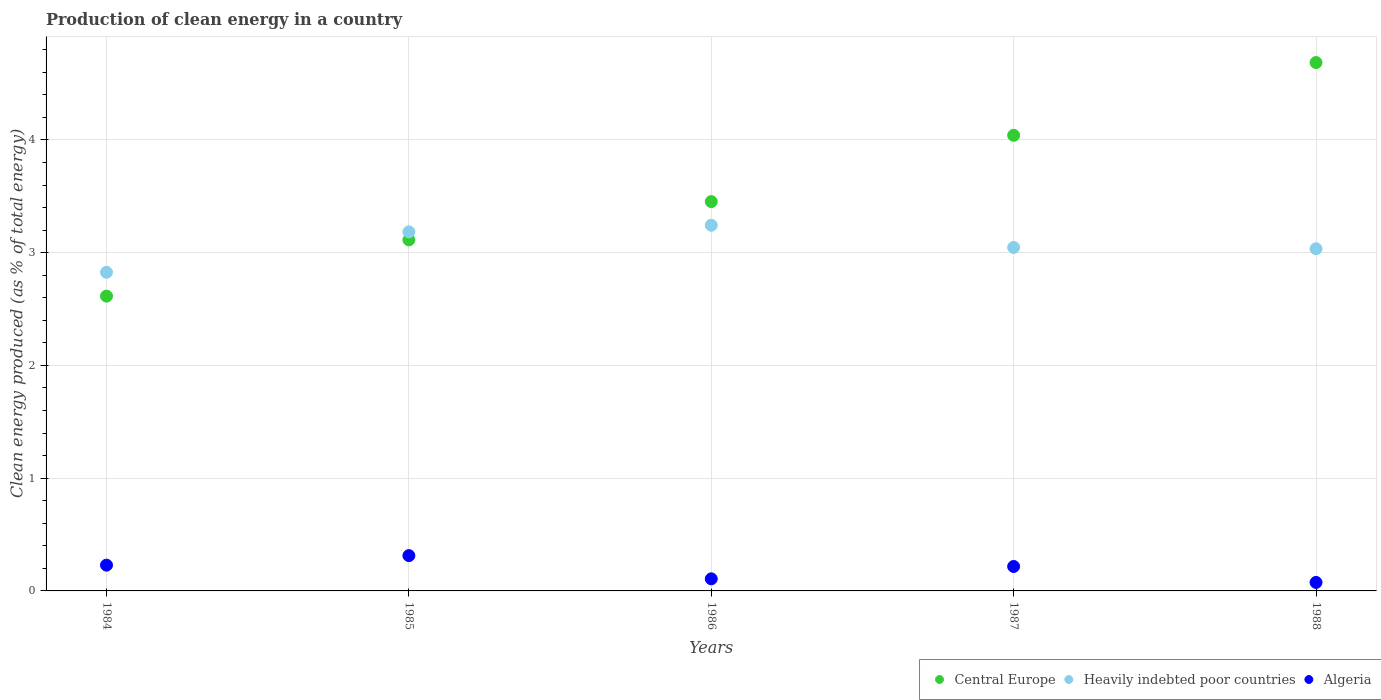How many different coloured dotlines are there?
Keep it short and to the point. 3. What is the percentage of clean energy produced in Algeria in 1988?
Your response must be concise. 0.08. Across all years, what is the maximum percentage of clean energy produced in Central Europe?
Give a very brief answer. 4.69. Across all years, what is the minimum percentage of clean energy produced in Heavily indebted poor countries?
Your answer should be very brief. 2.83. In which year was the percentage of clean energy produced in Central Europe minimum?
Offer a terse response. 1984. What is the total percentage of clean energy produced in Heavily indebted poor countries in the graph?
Provide a short and direct response. 15.34. What is the difference between the percentage of clean energy produced in Algeria in 1985 and that in 1988?
Your response must be concise. 0.24. What is the difference between the percentage of clean energy produced in Algeria in 1985 and the percentage of clean energy produced in Central Europe in 1988?
Keep it short and to the point. -4.37. What is the average percentage of clean energy produced in Heavily indebted poor countries per year?
Your answer should be very brief. 3.07. In the year 1984, what is the difference between the percentage of clean energy produced in Central Europe and percentage of clean energy produced in Algeria?
Your answer should be very brief. 2.39. What is the ratio of the percentage of clean energy produced in Heavily indebted poor countries in 1984 to that in 1985?
Keep it short and to the point. 0.89. Is the percentage of clean energy produced in Central Europe in 1986 less than that in 1988?
Provide a succinct answer. Yes. Is the difference between the percentage of clean energy produced in Central Europe in 1984 and 1985 greater than the difference between the percentage of clean energy produced in Algeria in 1984 and 1985?
Offer a very short reply. No. What is the difference between the highest and the second highest percentage of clean energy produced in Heavily indebted poor countries?
Your answer should be very brief. 0.06. What is the difference between the highest and the lowest percentage of clean energy produced in Central Europe?
Offer a very short reply. 2.07. In how many years, is the percentage of clean energy produced in Heavily indebted poor countries greater than the average percentage of clean energy produced in Heavily indebted poor countries taken over all years?
Ensure brevity in your answer.  2. Is the percentage of clean energy produced in Heavily indebted poor countries strictly greater than the percentage of clean energy produced in Algeria over the years?
Make the answer very short. Yes. How many dotlines are there?
Your response must be concise. 3. How many years are there in the graph?
Provide a short and direct response. 5. Does the graph contain grids?
Your answer should be compact. Yes. Where does the legend appear in the graph?
Offer a terse response. Bottom right. How many legend labels are there?
Provide a short and direct response. 3. How are the legend labels stacked?
Keep it short and to the point. Horizontal. What is the title of the graph?
Make the answer very short. Production of clean energy in a country. What is the label or title of the Y-axis?
Provide a short and direct response. Clean energy produced (as % of total energy). What is the Clean energy produced (as % of total energy) in Central Europe in 1984?
Ensure brevity in your answer.  2.61. What is the Clean energy produced (as % of total energy) in Heavily indebted poor countries in 1984?
Your answer should be compact. 2.83. What is the Clean energy produced (as % of total energy) in Algeria in 1984?
Give a very brief answer. 0.23. What is the Clean energy produced (as % of total energy) in Central Europe in 1985?
Make the answer very short. 3.11. What is the Clean energy produced (as % of total energy) of Heavily indebted poor countries in 1985?
Provide a succinct answer. 3.18. What is the Clean energy produced (as % of total energy) of Algeria in 1985?
Keep it short and to the point. 0.31. What is the Clean energy produced (as % of total energy) in Central Europe in 1986?
Provide a short and direct response. 3.45. What is the Clean energy produced (as % of total energy) in Heavily indebted poor countries in 1986?
Your answer should be very brief. 3.24. What is the Clean energy produced (as % of total energy) of Algeria in 1986?
Provide a short and direct response. 0.11. What is the Clean energy produced (as % of total energy) of Central Europe in 1987?
Offer a very short reply. 4.04. What is the Clean energy produced (as % of total energy) in Heavily indebted poor countries in 1987?
Offer a terse response. 3.05. What is the Clean energy produced (as % of total energy) of Algeria in 1987?
Provide a short and direct response. 0.22. What is the Clean energy produced (as % of total energy) in Central Europe in 1988?
Provide a short and direct response. 4.69. What is the Clean energy produced (as % of total energy) in Heavily indebted poor countries in 1988?
Give a very brief answer. 3.04. What is the Clean energy produced (as % of total energy) of Algeria in 1988?
Provide a short and direct response. 0.08. Across all years, what is the maximum Clean energy produced (as % of total energy) of Central Europe?
Your answer should be very brief. 4.69. Across all years, what is the maximum Clean energy produced (as % of total energy) in Heavily indebted poor countries?
Make the answer very short. 3.24. Across all years, what is the maximum Clean energy produced (as % of total energy) in Algeria?
Ensure brevity in your answer.  0.31. Across all years, what is the minimum Clean energy produced (as % of total energy) of Central Europe?
Offer a very short reply. 2.61. Across all years, what is the minimum Clean energy produced (as % of total energy) in Heavily indebted poor countries?
Your answer should be very brief. 2.83. Across all years, what is the minimum Clean energy produced (as % of total energy) of Algeria?
Provide a succinct answer. 0.08. What is the total Clean energy produced (as % of total energy) of Central Europe in the graph?
Ensure brevity in your answer.  17.91. What is the total Clean energy produced (as % of total energy) in Heavily indebted poor countries in the graph?
Offer a very short reply. 15.34. What is the difference between the Clean energy produced (as % of total energy) of Central Europe in 1984 and that in 1985?
Give a very brief answer. -0.5. What is the difference between the Clean energy produced (as % of total energy) of Heavily indebted poor countries in 1984 and that in 1985?
Provide a succinct answer. -0.36. What is the difference between the Clean energy produced (as % of total energy) of Algeria in 1984 and that in 1985?
Give a very brief answer. -0.08. What is the difference between the Clean energy produced (as % of total energy) of Central Europe in 1984 and that in 1986?
Your response must be concise. -0.84. What is the difference between the Clean energy produced (as % of total energy) in Heavily indebted poor countries in 1984 and that in 1986?
Provide a short and direct response. -0.42. What is the difference between the Clean energy produced (as % of total energy) in Algeria in 1984 and that in 1986?
Offer a very short reply. 0.12. What is the difference between the Clean energy produced (as % of total energy) of Central Europe in 1984 and that in 1987?
Offer a very short reply. -1.43. What is the difference between the Clean energy produced (as % of total energy) of Heavily indebted poor countries in 1984 and that in 1987?
Your answer should be very brief. -0.22. What is the difference between the Clean energy produced (as % of total energy) of Algeria in 1984 and that in 1987?
Provide a succinct answer. 0.01. What is the difference between the Clean energy produced (as % of total energy) in Central Europe in 1984 and that in 1988?
Your response must be concise. -2.07. What is the difference between the Clean energy produced (as % of total energy) in Heavily indebted poor countries in 1984 and that in 1988?
Provide a succinct answer. -0.21. What is the difference between the Clean energy produced (as % of total energy) in Algeria in 1984 and that in 1988?
Your answer should be compact. 0.15. What is the difference between the Clean energy produced (as % of total energy) of Central Europe in 1985 and that in 1986?
Make the answer very short. -0.34. What is the difference between the Clean energy produced (as % of total energy) in Heavily indebted poor countries in 1985 and that in 1986?
Provide a short and direct response. -0.06. What is the difference between the Clean energy produced (as % of total energy) of Algeria in 1985 and that in 1986?
Make the answer very short. 0.21. What is the difference between the Clean energy produced (as % of total energy) in Central Europe in 1985 and that in 1987?
Your answer should be very brief. -0.93. What is the difference between the Clean energy produced (as % of total energy) in Heavily indebted poor countries in 1985 and that in 1987?
Your response must be concise. 0.14. What is the difference between the Clean energy produced (as % of total energy) in Algeria in 1985 and that in 1987?
Your response must be concise. 0.1. What is the difference between the Clean energy produced (as % of total energy) in Central Europe in 1985 and that in 1988?
Give a very brief answer. -1.57. What is the difference between the Clean energy produced (as % of total energy) in Heavily indebted poor countries in 1985 and that in 1988?
Your answer should be very brief. 0.15. What is the difference between the Clean energy produced (as % of total energy) of Algeria in 1985 and that in 1988?
Give a very brief answer. 0.24. What is the difference between the Clean energy produced (as % of total energy) of Central Europe in 1986 and that in 1987?
Offer a very short reply. -0.59. What is the difference between the Clean energy produced (as % of total energy) of Heavily indebted poor countries in 1986 and that in 1987?
Keep it short and to the point. 0.2. What is the difference between the Clean energy produced (as % of total energy) in Algeria in 1986 and that in 1987?
Your response must be concise. -0.11. What is the difference between the Clean energy produced (as % of total energy) in Central Europe in 1986 and that in 1988?
Give a very brief answer. -1.23. What is the difference between the Clean energy produced (as % of total energy) of Heavily indebted poor countries in 1986 and that in 1988?
Your answer should be very brief. 0.21. What is the difference between the Clean energy produced (as % of total energy) in Algeria in 1986 and that in 1988?
Your answer should be very brief. 0.03. What is the difference between the Clean energy produced (as % of total energy) of Central Europe in 1987 and that in 1988?
Keep it short and to the point. -0.65. What is the difference between the Clean energy produced (as % of total energy) of Heavily indebted poor countries in 1987 and that in 1988?
Ensure brevity in your answer.  0.01. What is the difference between the Clean energy produced (as % of total energy) in Algeria in 1987 and that in 1988?
Ensure brevity in your answer.  0.14. What is the difference between the Clean energy produced (as % of total energy) of Central Europe in 1984 and the Clean energy produced (as % of total energy) of Heavily indebted poor countries in 1985?
Keep it short and to the point. -0.57. What is the difference between the Clean energy produced (as % of total energy) in Central Europe in 1984 and the Clean energy produced (as % of total energy) in Algeria in 1985?
Offer a terse response. 2.3. What is the difference between the Clean energy produced (as % of total energy) of Heavily indebted poor countries in 1984 and the Clean energy produced (as % of total energy) of Algeria in 1985?
Make the answer very short. 2.51. What is the difference between the Clean energy produced (as % of total energy) of Central Europe in 1984 and the Clean energy produced (as % of total energy) of Heavily indebted poor countries in 1986?
Ensure brevity in your answer.  -0.63. What is the difference between the Clean energy produced (as % of total energy) in Central Europe in 1984 and the Clean energy produced (as % of total energy) in Algeria in 1986?
Make the answer very short. 2.51. What is the difference between the Clean energy produced (as % of total energy) in Heavily indebted poor countries in 1984 and the Clean energy produced (as % of total energy) in Algeria in 1986?
Make the answer very short. 2.72. What is the difference between the Clean energy produced (as % of total energy) of Central Europe in 1984 and the Clean energy produced (as % of total energy) of Heavily indebted poor countries in 1987?
Your response must be concise. -0.43. What is the difference between the Clean energy produced (as % of total energy) in Central Europe in 1984 and the Clean energy produced (as % of total energy) in Algeria in 1987?
Your answer should be very brief. 2.4. What is the difference between the Clean energy produced (as % of total energy) in Heavily indebted poor countries in 1984 and the Clean energy produced (as % of total energy) in Algeria in 1987?
Offer a terse response. 2.61. What is the difference between the Clean energy produced (as % of total energy) of Central Europe in 1984 and the Clean energy produced (as % of total energy) of Heavily indebted poor countries in 1988?
Your response must be concise. -0.42. What is the difference between the Clean energy produced (as % of total energy) of Central Europe in 1984 and the Clean energy produced (as % of total energy) of Algeria in 1988?
Provide a succinct answer. 2.54. What is the difference between the Clean energy produced (as % of total energy) in Heavily indebted poor countries in 1984 and the Clean energy produced (as % of total energy) in Algeria in 1988?
Your answer should be compact. 2.75. What is the difference between the Clean energy produced (as % of total energy) in Central Europe in 1985 and the Clean energy produced (as % of total energy) in Heavily indebted poor countries in 1986?
Provide a short and direct response. -0.13. What is the difference between the Clean energy produced (as % of total energy) in Central Europe in 1985 and the Clean energy produced (as % of total energy) in Algeria in 1986?
Ensure brevity in your answer.  3.01. What is the difference between the Clean energy produced (as % of total energy) of Heavily indebted poor countries in 1985 and the Clean energy produced (as % of total energy) of Algeria in 1986?
Offer a very short reply. 3.08. What is the difference between the Clean energy produced (as % of total energy) in Central Europe in 1985 and the Clean energy produced (as % of total energy) in Heavily indebted poor countries in 1987?
Ensure brevity in your answer.  0.07. What is the difference between the Clean energy produced (as % of total energy) of Central Europe in 1985 and the Clean energy produced (as % of total energy) of Algeria in 1987?
Give a very brief answer. 2.9. What is the difference between the Clean energy produced (as % of total energy) of Heavily indebted poor countries in 1985 and the Clean energy produced (as % of total energy) of Algeria in 1987?
Ensure brevity in your answer.  2.97. What is the difference between the Clean energy produced (as % of total energy) in Central Europe in 1985 and the Clean energy produced (as % of total energy) in Heavily indebted poor countries in 1988?
Your response must be concise. 0.08. What is the difference between the Clean energy produced (as % of total energy) in Central Europe in 1985 and the Clean energy produced (as % of total energy) in Algeria in 1988?
Provide a short and direct response. 3.04. What is the difference between the Clean energy produced (as % of total energy) in Heavily indebted poor countries in 1985 and the Clean energy produced (as % of total energy) in Algeria in 1988?
Ensure brevity in your answer.  3.11. What is the difference between the Clean energy produced (as % of total energy) in Central Europe in 1986 and the Clean energy produced (as % of total energy) in Heavily indebted poor countries in 1987?
Offer a terse response. 0.41. What is the difference between the Clean energy produced (as % of total energy) of Central Europe in 1986 and the Clean energy produced (as % of total energy) of Algeria in 1987?
Make the answer very short. 3.24. What is the difference between the Clean energy produced (as % of total energy) in Heavily indebted poor countries in 1986 and the Clean energy produced (as % of total energy) in Algeria in 1987?
Your answer should be very brief. 3.03. What is the difference between the Clean energy produced (as % of total energy) of Central Europe in 1986 and the Clean energy produced (as % of total energy) of Heavily indebted poor countries in 1988?
Ensure brevity in your answer.  0.42. What is the difference between the Clean energy produced (as % of total energy) of Central Europe in 1986 and the Clean energy produced (as % of total energy) of Algeria in 1988?
Give a very brief answer. 3.38. What is the difference between the Clean energy produced (as % of total energy) in Heavily indebted poor countries in 1986 and the Clean energy produced (as % of total energy) in Algeria in 1988?
Offer a very short reply. 3.17. What is the difference between the Clean energy produced (as % of total energy) in Central Europe in 1987 and the Clean energy produced (as % of total energy) in Heavily indebted poor countries in 1988?
Provide a succinct answer. 1.01. What is the difference between the Clean energy produced (as % of total energy) in Central Europe in 1987 and the Clean energy produced (as % of total energy) in Algeria in 1988?
Offer a terse response. 3.97. What is the difference between the Clean energy produced (as % of total energy) in Heavily indebted poor countries in 1987 and the Clean energy produced (as % of total energy) in Algeria in 1988?
Make the answer very short. 2.97. What is the average Clean energy produced (as % of total energy) of Central Europe per year?
Give a very brief answer. 3.58. What is the average Clean energy produced (as % of total energy) in Heavily indebted poor countries per year?
Ensure brevity in your answer.  3.07. What is the average Clean energy produced (as % of total energy) in Algeria per year?
Offer a terse response. 0.19. In the year 1984, what is the difference between the Clean energy produced (as % of total energy) in Central Europe and Clean energy produced (as % of total energy) in Heavily indebted poor countries?
Your response must be concise. -0.21. In the year 1984, what is the difference between the Clean energy produced (as % of total energy) of Central Europe and Clean energy produced (as % of total energy) of Algeria?
Make the answer very short. 2.39. In the year 1984, what is the difference between the Clean energy produced (as % of total energy) in Heavily indebted poor countries and Clean energy produced (as % of total energy) in Algeria?
Keep it short and to the point. 2.6. In the year 1985, what is the difference between the Clean energy produced (as % of total energy) in Central Europe and Clean energy produced (as % of total energy) in Heavily indebted poor countries?
Provide a short and direct response. -0.07. In the year 1985, what is the difference between the Clean energy produced (as % of total energy) of Central Europe and Clean energy produced (as % of total energy) of Algeria?
Provide a short and direct response. 2.8. In the year 1985, what is the difference between the Clean energy produced (as % of total energy) in Heavily indebted poor countries and Clean energy produced (as % of total energy) in Algeria?
Offer a terse response. 2.87. In the year 1986, what is the difference between the Clean energy produced (as % of total energy) in Central Europe and Clean energy produced (as % of total energy) in Heavily indebted poor countries?
Make the answer very short. 0.21. In the year 1986, what is the difference between the Clean energy produced (as % of total energy) in Central Europe and Clean energy produced (as % of total energy) in Algeria?
Give a very brief answer. 3.35. In the year 1986, what is the difference between the Clean energy produced (as % of total energy) in Heavily indebted poor countries and Clean energy produced (as % of total energy) in Algeria?
Your response must be concise. 3.14. In the year 1987, what is the difference between the Clean energy produced (as % of total energy) of Central Europe and Clean energy produced (as % of total energy) of Algeria?
Your response must be concise. 3.82. In the year 1987, what is the difference between the Clean energy produced (as % of total energy) in Heavily indebted poor countries and Clean energy produced (as % of total energy) in Algeria?
Keep it short and to the point. 2.83. In the year 1988, what is the difference between the Clean energy produced (as % of total energy) of Central Europe and Clean energy produced (as % of total energy) of Heavily indebted poor countries?
Offer a very short reply. 1.65. In the year 1988, what is the difference between the Clean energy produced (as % of total energy) in Central Europe and Clean energy produced (as % of total energy) in Algeria?
Offer a very short reply. 4.61. In the year 1988, what is the difference between the Clean energy produced (as % of total energy) in Heavily indebted poor countries and Clean energy produced (as % of total energy) in Algeria?
Offer a terse response. 2.96. What is the ratio of the Clean energy produced (as % of total energy) of Central Europe in 1984 to that in 1985?
Give a very brief answer. 0.84. What is the ratio of the Clean energy produced (as % of total energy) in Heavily indebted poor countries in 1984 to that in 1985?
Offer a very short reply. 0.89. What is the ratio of the Clean energy produced (as % of total energy) of Algeria in 1984 to that in 1985?
Make the answer very short. 0.73. What is the ratio of the Clean energy produced (as % of total energy) of Central Europe in 1984 to that in 1986?
Your response must be concise. 0.76. What is the ratio of the Clean energy produced (as % of total energy) of Heavily indebted poor countries in 1984 to that in 1986?
Offer a very short reply. 0.87. What is the ratio of the Clean energy produced (as % of total energy) in Algeria in 1984 to that in 1986?
Your answer should be compact. 2.13. What is the ratio of the Clean energy produced (as % of total energy) in Central Europe in 1984 to that in 1987?
Your answer should be compact. 0.65. What is the ratio of the Clean energy produced (as % of total energy) of Heavily indebted poor countries in 1984 to that in 1987?
Provide a succinct answer. 0.93. What is the ratio of the Clean energy produced (as % of total energy) in Algeria in 1984 to that in 1987?
Make the answer very short. 1.05. What is the ratio of the Clean energy produced (as % of total energy) of Central Europe in 1984 to that in 1988?
Offer a very short reply. 0.56. What is the ratio of the Clean energy produced (as % of total energy) in Heavily indebted poor countries in 1984 to that in 1988?
Provide a short and direct response. 0.93. What is the ratio of the Clean energy produced (as % of total energy) of Algeria in 1984 to that in 1988?
Offer a very short reply. 3.04. What is the ratio of the Clean energy produced (as % of total energy) in Central Europe in 1985 to that in 1986?
Your answer should be very brief. 0.9. What is the ratio of the Clean energy produced (as % of total energy) in Algeria in 1985 to that in 1986?
Provide a short and direct response. 2.92. What is the ratio of the Clean energy produced (as % of total energy) in Central Europe in 1985 to that in 1987?
Provide a succinct answer. 0.77. What is the ratio of the Clean energy produced (as % of total energy) of Heavily indebted poor countries in 1985 to that in 1987?
Your answer should be very brief. 1.05. What is the ratio of the Clean energy produced (as % of total energy) in Algeria in 1985 to that in 1987?
Your answer should be compact. 1.44. What is the ratio of the Clean energy produced (as % of total energy) in Central Europe in 1985 to that in 1988?
Ensure brevity in your answer.  0.66. What is the ratio of the Clean energy produced (as % of total energy) of Heavily indebted poor countries in 1985 to that in 1988?
Provide a short and direct response. 1.05. What is the ratio of the Clean energy produced (as % of total energy) of Algeria in 1985 to that in 1988?
Keep it short and to the point. 4.16. What is the ratio of the Clean energy produced (as % of total energy) of Central Europe in 1986 to that in 1987?
Make the answer very short. 0.85. What is the ratio of the Clean energy produced (as % of total energy) of Heavily indebted poor countries in 1986 to that in 1987?
Keep it short and to the point. 1.06. What is the ratio of the Clean energy produced (as % of total energy) of Algeria in 1986 to that in 1987?
Keep it short and to the point. 0.49. What is the ratio of the Clean energy produced (as % of total energy) of Central Europe in 1986 to that in 1988?
Ensure brevity in your answer.  0.74. What is the ratio of the Clean energy produced (as % of total energy) in Heavily indebted poor countries in 1986 to that in 1988?
Your response must be concise. 1.07. What is the ratio of the Clean energy produced (as % of total energy) of Algeria in 1986 to that in 1988?
Offer a very short reply. 1.42. What is the ratio of the Clean energy produced (as % of total energy) of Central Europe in 1987 to that in 1988?
Your response must be concise. 0.86. What is the ratio of the Clean energy produced (as % of total energy) in Heavily indebted poor countries in 1987 to that in 1988?
Your answer should be compact. 1. What is the ratio of the Clean energy produced (as % of total energy) of Algeria in 1987 to that in 1988?
Offer a terse response. 2.88. What is the difference between the highest and the second highest Clean energy produced (as % of total energy) of Central Europe?
Give a very brief answer. 0.65. What is the difference between the highest and the second highest Clean energy produced (as % of total energy) in Heavily indebted poor countries?
Your response must be concise. 0.06. What is the difference between the highest and the second highest Clean energy produced (as % of total energy) of Algeria?
Ensure brevity in your answer.  0.08. What is the difference between the highest and the lowest Clean energy produced (as % of total energy) in Central Europe?
Offer a very short reply. 2.07. What is the difference between the highest and the lowest Clean energy produced (as % of total energy) of Heavily indebted poor countries?
Offer a very short reply. 0.42. What is the difference between the highest and the lowest Clean energy produced (as % of total energy) in Algeria?
Ensure brevity in your answer.  0.24. 